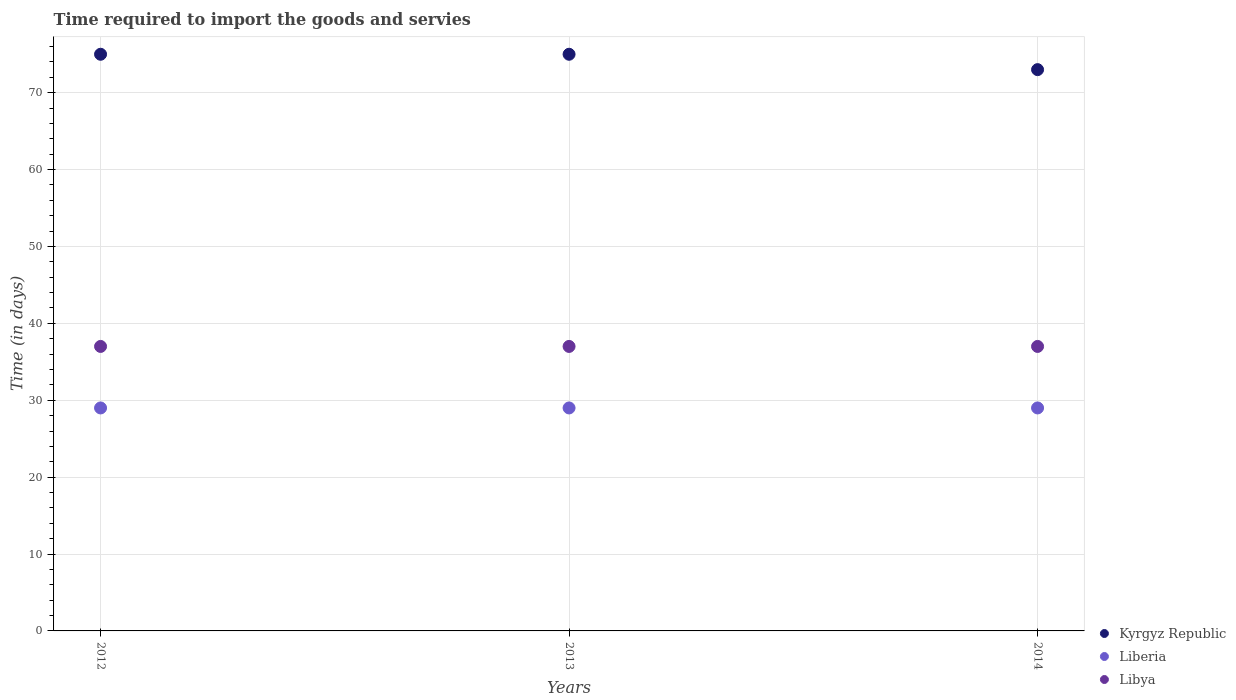How many different coloured dotlines are there?
Provide a short and direct response. 3. What is the number of days required to import the goods and services in Libya in 2013?
Your answer should be compact. 37. Across all years, what is the maximum number of days required to import the goods and services in Kyrgyz Republic?
Provide a short and direct response. 75. What is the difference between the number of days required to import the goods and services in Kyrgyz Republic in 2013 and the number of days required to import the goods and services in Libya in 2014?
Keep it short and to the point. 38. What is the average number of days required to import the goods and services in Libya per year?
Your answer should be compact. 37. In the year 2014, what is the difference between the number of days required to import the goods and services in Libya and number of days required to import the goods and services in Kyrgyz Republic?
Provide a short and direct response. -36. In how many years, is the number of days required to import the goods and services in Kyrgyz Republic greater than 72 days?
Make the answer very short. 3. Is the number of days required to import the goods and services in Libya in 2012 less than that in 2014?
Give a very brief answer. No. What is the difference between the highest and the second highest number of days required to import the goods and services in Libya?
Give a very brief answer. 0. Is it the case that in every year, the sum of the number of days required to import the goods and services in Kyrgyz Republic and number of days required to import the goods and services in Libya  is greater than the number of days required to import the goods and services in Liberia?
Give a very brief answer. Yes. How many dotlines are there?
Provide a succinct answer. 3. How many years are there in the graph?
Offer a terse response. 3. Are the values on the major ticks of Y-axis written in scientific E-notation?
Make the answer very short. No. Does the graph contain any zero values?
Make the answer very short. No. Does the graph contain grids?
Offer a terse response. Yes. How are the legend labels stacked?
Keep it short and to the point. Vertical. What is the title of the graph?
Make the answer very short. Time required to import the goods and servies. What is the label or title of the X-axis?
Your answer should be very brief. Years. What is the label or title of the Y-axis?
Your answer should be compact. Time (in days). What is the Time (in days) of Libya in 2012?
Offer a terse response. 37. What is the Time (in days) of Kyrgyz Republic in 2013?
Offer a very short reply. 75. What is the Time (in days) in Liberia in 2013?
Keep it short and to the point. 29. What is the Time (in days) of Libya in 2014?
Provide a short and direct response. 37. Across all years, what is the maximum Time (in days) of Kyrgyz Republic?
Keep it short and to the point. 75. Across all years, what is the maximum Time (in days) of Libya?
Offer a very short reply. 37. Across all years, what is the minimum Time (in days) in Liberia?
Give a very brief answer. 29. What is the total Time (in days) of Kyrgyz Republic in the graph?
Offer a terse response. 223. What is the total Time (in days) of Libya in the graph?
Offer a very short reply. 111. What is the difference between the Time (in days) in Kyrgyz Republic in 2012 and that in 2013?
Ensure brevity in your answer.  0. What is the difference between the Time (in days) in Liberia in 2012 and that in 2013?
Make the answer very short. 0. What is the difference between the Time (in days) in Libya in 2012 and that in 2014?
Offer a terse response. 0. What is the difference between the Time (in days) in Kyrgyz Republic in 2013 and that in 2014?
Ensure brevity in your answer.  2. What is the difference between the Time (in days) of Liberia in 2013 and that in 2014?
Offer a terse response. 0. What is the difference between the Time (in days) in Kyrgyz Republic in 2012 and the Time (in days) in Liberia in 2013?
Your answer should be very brief. 46. What is the difference between the Time (in days) of Liberia in 2012 and the Time (in days) of Libya in 2013?
Your answer should be very brief. -8. What is the difference between the Time (in days) in Liberia in 2012 and the Time (in days) in Libya in 2014?
Provide a succinct answer. -8. What is the difference between the Time (in days) of Kyrgyz Republic in 2013 and the Time (in days) of Liberia in 2014?
Give a very brief answer. 46. What is the average Time (in days) of Kyrgyz Republic per year?
Your response must be concise. 74.33. What is the average Time (in days) in Libya per year?
Provide a short and direct response. 37. In the year 2012, what is the difference between the Time (in days) in Liberia and Time (in days) in Libya?
Provide a short and direct response. -8. In the year 2013, what is the difference between the Time (in days) in Kyrgyz Republic and Time (in days) in Liberia?
Give a very brief answer. 46. What is the ratio of the Time (in days) in Kyrgyz Republic in 2012 to that in 2013?
Offer a very short reply. 1. What is the ratio of the Time (in days) in Libya in 2012 to that in 2013?
Ensure brevity in your answer.  1. What is the ratio of the Time (in days) in Kyrgyz Republic in 2012 to that in 2014?
Offer a very short reply. 1.03. What is the ratio of the Time (in days) of Liberia in 2012 to that in 2014?
Your answer should be very brief. 1. What is the ratio of the Time (in days) of Libya in 2012 to that in 2014?
Your response must be concise. 1. What is the ratio of the Time (in days) of Kyrgyz Republic in 2013 to that in 2014?
Offer a terse response. 1.03. What is the ratio of the Time (in days) of Libya in 2013 to that in 2014?
Ensure brevity in your answer.  1. What is the difference between the highest and the second highest Time (in days) in Liberia?
Your answer should be compact. 0. What is the difference between the highest and the lowest Time (in days) in Kyrgyz Republic?
Provide a short and direct response. 2. 